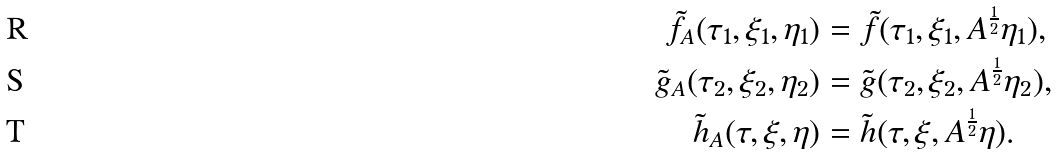<formula> <loc_0><loc_0><loc_500><loc_500>\tilde { f } _ { A } ( \tau _ { 1 } , \xi _ { 1 } , \eta _ { 1 } ) & = \tilde { f } ( \tau _ { 1 } , \xi _ { 1 } , A ^ { \frac { 1 } { 2 } } \eta _ { 1 } ) , \\ \tilde { g } _ { A } ( \tau _ { 2 } , \xi _ { 2 } , \eta _ { 2 } ) & = \tilde { g } ( \tau _ { 2 } , \xi _ { 2 } , A ^ { \frac { 1 } { 2 } } \eta _ { 2 } ) , \\ \tilde { h } _ { A } ( \tau , \xi , \eta ) & = \tilde { h } ( \tau , \xi , A ^ { \frac { 1 } { 2 } } \eta ) .</formula> 